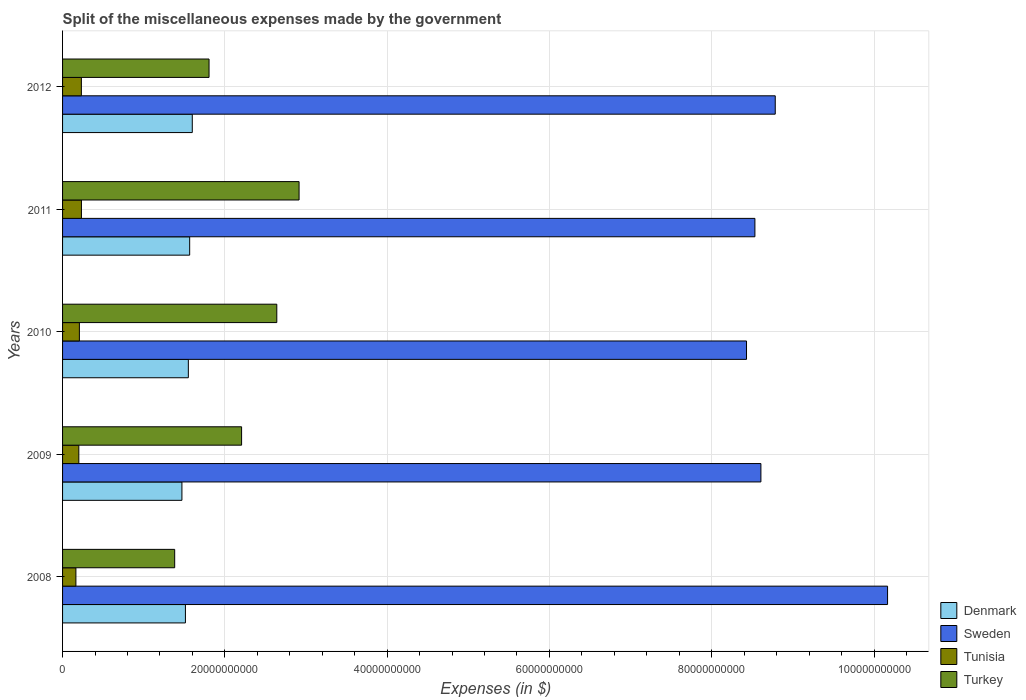How many bars are there on the 4th tick from the top?
Your answer should be very brief. 4. How many bars are there on the 2nd tick from the bottom?
Provide a succinct answer. 4. What is the label of the 1st group of bars from the top?
Keep it short and to the point. 2012. What is the miscellaneous expenses made by the government in Denmark in 2012?
Your response must be concise. 1.60e+1. Across all years, what is the maximum miscellaneous expenses made by the government in Denmark?
Make the answer very short. 1.60e+1. Across all years, what is the minimum miscellaneous expenses made by the government in Denmark?
Your response must be concise. 1.47e+1. In which year was the miscellaneous expenses made by the government in Denmark maximum?
Give a very brief answer. 2012. In which year was the miscellaneous expenses made by the government in Denmark minimum?
Offer a very short reply. 2009. What is the total miscellaneous expenses made by the government in Tunisia in the graph?
Make the answer very short. 1.04e+1. What is the difference between the miscellaneous expenses made by the government in Sweden in 2010 and that in 2012?
Keep it short and to the point. -3.54e+09. What is the difference between the miscellaneous expenses made by the government in Turkey in 2010 and the miscellaneous expenses made by the government in Sweden in 2012?
Ensure brevity in your answer.  -6.14e+1. What is the average miscellaneous expenses made by the government in Turkey per year?
Make the answer very short. 2.19e+1. In the year 2010, what is the difference between the miscellaneous expenses made by the government in Sweden and miscellaneous expenses made by the government in Denmark?
Your answer should be very brief. 6.88e+1. What is the ratio of the miscellaneous expenses made by the government in Denmark in 2009 to that in 2011?
Make the answer very short. 0.94. What is the difference between the highest and the second highest miscellaneous expenses made by the government in Tunisia?
Keep it short and to the point. 7.20e+06. What is the difference between the highest and the lowest miscellaneous expenses made by the government in Denmark?
Offer a very short reply. 1.28e+09. What does the 4th bar from the top in 2012 represents?
Provide a short and direct response. Denmark. How many bars are there?
Offer a terse response. 20. Are all the bars in the graph horizontal?
Provide a succinct answer. Yes. Where does the legend appear in the graph?
Give a very brief answer. Bottom right. What is the title of the graph?
Ensure brevity in your answer.  Split of the miscellaneous expenses made by the government. What is the label or title of the X-axis?
Keep it short and to the point. Expenses (in $). What is the label or title of the Y-axis?
Provide a succinct answer. Years. What is the Expenses (in $) of Denmark in 2008?
Your response must be concise. 1.51e+1. What is the Expenses (in $) in Sweden in 2008?
Give a very brief answer. 1.02e+11. What is the Expenses (in $) of Tunisia in 2008?
Offer a terse response. 1.64e+09. What is the Expenses (in $) of Turkey in 2008?
Offer a very short reply. 1.38e+1. What is the Expenses (in $) of Denmark in 2009?
Offer a very short reply. 1.47e+1. What is the Expenses (in $) in Sweden in 2009?
Ensure brevity in your answer.  8.61e+1. What is the Expenses (in $) of Tunisia in 2009?
Keep it short and to the point. 2.00e+09. What is the Expenses (in $) of Turkey in 2009?
Offer a terse response. 2.21e+1. What is the Expenses (in $) of Denmark in 2010?
Your answer should be compact. 1.55e+1. What is the Expenses (in $) in Sweden in 2010?
Offer a terse response. 8.43e+1. What is the Expenses (in $) of Tunisia in 2010?
Offer a terse response. 2.07e+09. What is the Expenses (in $) in Turkey in 2010?
Provide a short and direct response. 2.64e+1. What is the Expenses (in $) of Denmark in 2011?
Your answer should be compact. 1.57e+1. What is the Expenses (in $) in Sweden in 2011?
Give a very brief answer. 8.53e+1. What is the Expenses (in $) in Tunisia in 2011?
Ensure brevity in your answer.  2.32e+09. What is the Expenses (in $) of Turkey in 2011?
Provide a succinct answer. 2.91e+1. What is the Expenses (in $) of Denmark in 2012?
Offer a very short reply. 1.60e+1. What is the Expenses (in $) in Sweden in 2012?
Offer a very short reply. 8.78e+1. What is the Expenses (in $) in Tunisia in 2012?
Your response must be concise. 2.32e+09. What is the Expenses (in $) of Turkey in 2012?
Provide a succinct answer. 1.81e+1. Across all years, what is the maximum Expenses (in $) in Denmark?
Your response must be concise. 1.60e+1. Across all years, what is the maximum Expenses (in $) in Sweden?
Ensure brevity in your answer.  1.02e+11. Across all years, what is the maximum Expenses (in $) of Tunisia?
Keep it short and to the point. 2.32e+09. Across all years, what is the maximum Expenses (in $) of Turkey?
Keep it short and to the point. 2.91e+1. Across all years, what is the minimum Expenses (in $) of Denmark?
Your answer should be very brief. 1.47e+1. Across all years, what is the minimum Expenses (in $) of Sweden?
Provide a succinct answer. 8.43e+1. Across all years, what is the minimum Expenses (in $) in Tunisia?
Provide a short and direct response. 1.64e+09. Across all years, what is the minimum Expenses (in $) in Turkey?
Offer a terse response. 1.38e+1. What is the total Expenses (in $) of Denmark in the graph?
Offer a terse response. 7.70e+1. What is the total Expenses (in $) in Sweden in the graph?
Ensure brevity in your answer.  4.45e+11. What is the total Expenses (in $) of Tunisia in the graph?
Offer a very short reply. 1.04e+1. What is the total Expenses (in $) of Turkey in the graph?
Offer a terse response. 1.09e+11. What is the difference between the Expenses (in $) in Denmark in 2008 and that in 2009?
Ensure brevity in your answer.  4.30e+08. What is the difference between the Expenses (in $) of Sweden in 2008 and that in 2009?
Give a very brief answer. 1.56e+1. What is the difference between the Expenses (in $) of Tunisia in 2008 and that in 2009?
Ensure brevity in your answer.  -3.60e+08. What is the difference between the Expenses (in $) in Turkey in 2008 and that in 2009?
Your answer should be compact. -8.25e+09. What is the difference between the Expenses (in $) of Denmark in 2008 and that in 2010?
Make the answer very short. -3.60e+08. What is the difference between the Expenses (in $) in Sweden in 2008 and that in 2010?
Keep it short and to the point. 1.74e+1. What is the difference between the Expenses (in $) in Tunisia in 2008 and that in 2010?
Offer a very short reply. -4.31e+08. What is the difference between the Expenses (in $) in Turkey in 2008 and that in 2010?
Your answer should be very brief. -1.26e+1. What is the difference between the Expenses (in $) in Denmark in 2008 and that in 2011?
Provide a succinct answer. -5.25e+08. What is the difference between the Expenses (in $) in Sweden in 2008 and that in 2011?
Offer a terse response. 1.63e+1. What is the difference between the Expenses (in $) in Tunisia in 2008 and that in 2011?
Make the answer very short. -6.82e+08. What is the difference between the Expenses (in $) of Turkey in 2008 and that in 2011?
Provide a short and direct response. -1.53e+1. What is the difference between the Expenses (in $) in Denmark in 2008 and that in 2012?
Provide a short and direct response. -8.46e+08. What is the difference between the Expenses (in $) of Sweden in 2008 and that in 2012?
Your answer should be very brief. 1.38e+1. What is the difference between the Expenses (in $) in Tunisia in 2008 and that in 2012?
Provide a short and direct response. -6.74e+08. What is the difference between the Expenses (in $) in Turkey in 2008 and that in 2012?
Give a very brief answer. -4.24e+09. What is the difference between the Expenses (in $) of Denmark in 2009 and that in 2010?
Provide a short and direct response. -7.90e+08. What is the difference between the Expenses (in $) in Sweden in 2009 and that in 2010?
Keep it short and to the point. 1.77e+09. What is the difference between the Expenses (in $) of Tunisia in 2009 and that in 2010?
Give a very brief answer. -7.06e+07. What is the difference between the Expenses (in $) in Turkey in 2009 and that in 2010?
Your answer should be compact. -4.34e+09. What is the difference between the Expenses (in $) in Denmark in 2009 and that in 2011?
Your response must be concise. -9.55e+08. What is the difference between the Expenses (in $) in Sweden in 2009 and that in 2011?
Provide a succinct answer. 7.40e+08. What is the difference between the Expenses (in $) of Tunisia in 2009 and that in 2011?
Ensure brevity in your answer.  -3.21e+08. What is the difference between the Expenses (in $) of Turkey in 2009 and that in 2011?
Keep it short and to the point. -7.08e+09. What is the difference between the Expenses (in $) in Denmark in 2009 and that in 2012?
Keep it short and to the point. -1.28e+09. What is the difference between the Expenses (in $) of Sweden in 2009 and that in 2012?
Offer a very short reply. -1.77e+09. What is the difference between the Expenses (in $) of Tunisia in 2009 and that in 2012?
Offer a terse response. -3.14e+08. What is the difference between the Expenses (in $) in Turkey in 2009 and that in 2012?
Give a very brief answer. 4.01e+09. What is the difference between the Expenses (in $) in Denmark in 2010 and that in 2011?
Keep it short and to the point. -1.65e+08. What is the difference between the Expenses (in $) of Sweden in 2010 and that in 2011?
Provide a succinct answer. -1.03e+09. What is the difference between the Expenses (in $) in Tunisia in 2010 and that in 2011?
Provide a succinct answer. -2.50e+08. What is the difference between the Expenses (in $) in Turkey in 2010 and that in 2011?
Provide a short and direct response. -2.75e+09. What is the difference between the Expenses (in $) of Denmark in 2010 and that in 2012?
Provide a succinct answer. -4.86e+08. What is the difference between the Expenses (in $) in Sweden in 2010 and that in 2012?
Ensure brevity in your answer.  -3.54e+09. What is the difference between the Expenses (in $) in Tunisia in 2010 and that in 2012?
Ensure brevity in your answer.  -2.43e+08. What is the difference between the Expenses (in $) in Turkey in 2010 and that in 2012?
Make the answer very short. 8.35e+09. What is the difference between the Expenses (in $) in Denmark in 2011 and that in 2012?
Offer a very short reply. -3.21e+08. What is the difference between the Expenses (in $) in Sweden in 2011 and that in 2012?
Make the answer very short. -2.51e+09. What is the difference between the Expenses (in $) of Tunisia in 2011 and that in 2012?
Keep it short and to the point. 7.20e+06. What is the difference between the Expenses (in $) in Turkey in 2011 and that in 2012?
Your answer should be compact. 1.11e+1. What is the difference between the Expenses (in $) in Denmark in 2008 and the Expenses (in $) in Sweden in 2009?
Your answer should be very brief. -7.09e+1. What is the difference between the Expenses (in $) of Denmark in 2008 and the Expenses (in $) of Tunisia in 2009?
Provide a short and direct response. 1.31e+1. What is the difference between the Expenses (in $) of Denmark in 2008 and the Expenses (in $) of Turkey in 2009?
Your answer should be compact. -6.92e+09. What is the difference between the Expenses (in $) of Sweden in 2008 and the Expenses (in $) of Tunisia in 2009?
Provide a succinct answer. 9.97e+1. What is the difference between the Expenses (in $) of Sweden in 2008 and the Expenses (in $) of Turkey in 2009?
Keep it short and to the point. 7.96e+1. What is the difference between the Expenses (in $) in Tunisia in 2008 and the Expenses (in $) in Turkey in 2009?
Your answer should be compact. -2.04e+1. What is the difference between the Expenses (in $) of Denmark in 2008 and the Expenses (in $) of Sweden in 2010?
Your answer should be very brief. -6.92e+1. What is the difference between the Expenses (in $) of Denmark in 2008 and the Expenses (in $) of Tunisia in 2010?
Your response must be concise. 1.31e+1. What is the difference between the Expenses (in $) of Denmark in 2008 and the Expenses (in $) of Turkey in 2010?
Ensure brevity in your answer.  -1.13e+1. What is the difference between the Expenses (in $) of Sweden in 2008 and the Expenses (in $) of Tunisia in 2010?
Your answer should be very brief. 9.96e+1. What is the difference between the Expenses (in $) in Sweden in 2008 and the Expenses (in $) in Turkey in 2010?
Your answer should be very brief. 7.53e+1. What is the difference between the Expenses (in $) of Tunisia in 2008 and the Expenses (in $) of Turkey in 2010?
Your answer should be very brief. -2.48e+1. What is the difference between the Expenses (in $) of Denmark in 2008 and the Expenses (in $) of Sweden in 2011?
Offer a very short reply. -7.02e+1. What is the difference between the Expenses (in $) in Denmark in 2008 and the Expenses (in $) in Tunisia in 2011?
Your answer should be very brief. 1.28e+1. What is the difference between the Expenses (in $) in Denmark in 2008 and the Expenses (in $) in Turkey in 2011?
Offer a terse response. -1.40e+1. What is the difference between the Expenses (in $) of Sweden in 2008 and the Expenses (in $) of Tunisia in 2011?
Give a very brief answer. 9.93e+1. What is the difference between the Expenses (in $) of Sweden in 2008 and the Expenses (in $) of Turkey in 2011?
Provide a succinct answer. 7.25e+1. What is the difference between the Expenses (in $) in Tunisia in 2008 and the Expenses (in $) in Turkey in 2011?
Your response must be concise. -2.75e+1. What is the difference between the Expenses (in $) of Denmark in 2008 and the Expenses (in $) of Sweden in 2012?
Offer a terse response. -7.27e+1. What is the difference between the Expenses (in $) of Denmark in 2008 and the Expenses (in $) of Tunisia in 2012?
Give a very brief answer. 1.28e+1. What is the difference between the Expenses (in $) in Denmark in 2008 and the Expenses (in $) in Turkey in 2012?
Your answer should be very brief. -2.91e+09. What is the difference between the Expenses (in $) of Sweden in 2008 and the Expenses (in $) of Tunisia in 2012?
Your response must be concise. 9.94e+1. What is the difference between the Expenses (in $) of Sweden in 2008 and the Expenses (in $) of Turkey in 2012?
Offer a terse response. 8.36e+1. What is the difference between the Expenses (in $) in Tunisia in 2008 and the Expenses (in $) in Turkey in 2012?
Offer a terse response. -1.64e+1. What is the difference between the Expenses (in $) in Denmark in 2009 and the Expenses (in $) in Sweden in 2010?
Provide a short and direct response. -6.96e+1. What is the difference between the Expenses (in $) of Denmark in 2009 and the Expenses (in $) of Tunisia in 2010?
Your answer should be very brief. 1.26e+1. What is the difference between the Expenses (in $) in Denmark in 2009 and the Expenses (in $) in Turkey in 2010?
Make the answer very short. -1.17e+1. What is the difference between the Expenses (in $) in Sweden in 2009 and the Expenses (in $) in Tunisia in 2010?
Your answer should be compact. 8.40e+1. What is the difference between the Expenses (in $) of Sweden in 2009 and the Expenses (in $) of Turkey in 2010?
Your answer should be compact. 5.97e+1. What is the difference between the Expenses (in $) of Tunisia in 2009 and the Expenses (in $) of Turkey in 2010?
Your answer should be compact. -2.44e+1. What is the difference between the Expenses (in $) of Denmark in 2009 and the Expenses (in $) of Sweden in 2011?
Provide a short and direct response. -7.06e+1. What is the difference between the Expenses (in $) in Denmark in 2009 and the Expenses (in $) in Tunisia in 2011?
Your answer should be compact. 1.24e+1. What is the difference between the Expenses (in $) of Denmark in 2009 and the Expenses (in $) of Turkey in 2011?
Give a very brief answer. -1.44e+1. What is the difference between the Expenses (in $) of Sweden in 2009 and the Expenses (in $) of Tunisia in 2011?
Offer a terse response. 8.37e+1. What is the difference between the Expenses (in $) of Sweden in 2009 and the Expenses (in $) of Turkey in 2011?
Offer a terse response. 5.69e+1. What is the difference between the Expenses (in $) of Tunisia in 2009 and the Expenses (in $) of Turkey in 2011?
Provide a succinct answer. -2.71e+1. What is the difference between the Expenses (in $) in Denmark in 2009 and the Expenses (in $) in Sweden in 2012?
Make the answer very short. -7.31e+1. What is the difference between the Expenses (in $) in Denmark in 2009 and the Expenses (in $) in Tunisia in 2012?
Your response must be concise. 1.24e+1. What is the difference between the Expenses (in $) in Denmark in 2009 and the Expenses (in $) in Turkey in 2012?
Offer a terse response. -3.34e+09. What is the difference between the Expenses (in $) of Sweden in 2009 and the Expenses (in $) of Tunisia in 2012?
Make the answer very short. 8.37e+1. What is the difference between the Expenses (in $) in Sweden in 2009 and the Expenses (in $) in Turkey in 2012?
Give a very brief answer. 6.80e+1. What is the difference between the Expenses (in $) in Tunisia in 2009 and the Expenses (in $) in Turkey in 2012?
Ensure brevity in your answer.  -1.60e+1. What is the difference between the Expenses (in $) in Denmark in 2010 and the Expenses (in $) in Sweden in 2011?
Keep it short and to the point. -6.98e+1. What is the difference between the Expenses (in $) in Denmark in 2010 and the Expenses (in $) in Tunisia in 2011?
Keep it short and to the point. 1.32e+1. What is the difference between the Expenses (in $) in Denmark in 2010 and the Expenses (in $) in Turkey in 2011?
Provide a succinct answer. -1.36e+1. What is the difference between the Expenses (in $) in Sweden in 2010 and the Expenses (in $) in Tunisia in 2011?
Give a very brief answer. 8.20e+1. What is the difference between the Expenses (in $) in Sweden in 2010 and the Expenses (in $) in Turkey in 2011?
Ensure brevity in your answer.  5.51e+1. What is the difference between the Expenses (in $) in Tunisia in 2010 and the Expenses (in $) in Turkey in 2011?
Make the answer very short. -2.71e+1. What is the difference between the Expenses (in $) of Denmark in 2010 and the Expenses (in $) of Sweden in 2012?
Make the answer very short. -7.23e+1. What is the difference between the Expenses (in $) of Denmark in 2010 and the Expenses (in $) of Tunisia in 2012?
Your answer should be very brief. 1.32e+1. What is the difference between the Expenses (in $) in Denmark in 2010 and the Expenses (in $) in Turkey in 2012?
Offer a very short reply. -2.55e+09. What is the difference between the Expenses (in $) of Sweden in 2010 and the Expenses (in $) of Tunisia in 2012?
Your response must be concise. 8.20e+1. What is the difference between the Expenses (in $) of Sweden in 2010 and the Expenses (in $) of Turkey in 2012?
Keep it short and to the point. 6.62e+1. What is the difference between the Expenses (in $) in Tunisia in 2010 and the Expenses (in $) in Turkey in 2012?
Your answer should be compact. -1.60e+1. What is the difference between the Expenses (in $) of Denmark in 2011 and the Expenses (in $) of Sweden in 2012?
Provide a succinct answer. -7.22e+1. What is the difference between the Expenses (in $) of Denmark in 2011 and the Expenses (in $) of Tunisia in 2012?
Ensure brevity in your answer.  1.33e+1. What is the difference between the Expenses (in $) in Denmark in 2011 and the Expenses (in $) in Turkey in 2012?
Your answer should be compact. -2.39e+09. What is the difference between the Expenses (in $) in Sweden in 2011 and the Expenses (in $) in Tunisia in 2012?
Your response must be concise. 8.30e+1. What is the difference between the Expenses (in $) of Sweden in 2011 and the Expenses (in $) of Turkey in 2012?
Your answer should be very brief. 6.73e+1. What is the difference between the Expenses (in $) in Tunisia in 2011 and the Expenses (in $) in Turkey in 2012?
Your answer should be compact. -1.57e+1. What is the average Expenses (in $) of Denmark per year?
Ensure brevity in your answer.  1.54e+1. What is the average Expenses (in $) of Sweden per year?
Offer a very short reply. 8.90e+1. What is the average Expenses (in $) in Tunisia per year?
Your response must be concise. 2.07e+09. What is the average Expenses (in $) in Turkey per year?
Your answer should be very brief. 2.19e+1. In the year 2008, what is the difference between the Expenses (in $) of Denmark and Expenses (in $) of Sweden?
Provide a succinct answer. -8.65e+1. In the year 2008, what is the difference between the Expenses (in $) in Denmark and Expenses (in $) in Tunisia?
Your response must be concise. 1.35e+1. In the year 2008, what is the difference between the Expenses (in $) of Denmark and Expenses (in $) of Turkey?
Your response must be concise. 1.32e+09. In the year 2008, what is the difference between the Expenses (in $) in Sweden and Expenses (in $) in Tunisia?
Give a very brief answer. 1.00e+11. In the year 2008, what is the difference between the Expenses (in $) of Sweden and Expenses (in $) of Turkey?
Keep it short and to the point. 8.79e+1. In the year 2008, what is the difference between the Expenses (in $) in Tunisia and Expenses (in $) in Turkey?
Ensure brevity in your answer.  -1.22e+1. In the year 2009, what is the difference between the Expenses (in $) in Denmark and Expenses (in $) in Sweden?
Ensure brevity in your answer.  -7.14e+1. In the year 2009, what is the difference between the Expenses (in $) in Denmark and Expenses (in $) in Tunisia?
Make the answer very short. 1.27e+1. In the year 2009, what is the difference between the Expenses (in $) of Denmark and Expenses (in $) of Turkey?
Your answer should be very brief. -7.35e+09. In the year 2009, what is the difference between the Expenses (in $) of Sweden and Expenses (in $) of Tunisia?
Your answer should be compact. 8.41e+1. In the year 2009, what is the difference between the Expenses (in $) of Sweden and Expenses (in $) of Turkey?
Provide a short and direct response. 6.40e+1. In the year 2009, what is the difference between the Expenses (in $) of Tunisia and Expenses (in $) of Turkey?
Provide a short and direct response. -2.01e+1. In the year 2010, what is the difference between the Expenses (in $) in Denmark and Expenses (in $) in Sweden?
Ensure brevity in your answer.  -6.88e+1. In the year 2010, what is the difference between the Expenses (in $) of Denmark and Expenses (in $) of Tunisia?
Offer a very short reply. 1.34e+1. In the year 2010, what is the difference between the Expenses (in $) in Denmark and Expenses (in $) in Turkey?
Your answer should be very brief. -1.09e+1. In the year 2010, what is the difference between the Expenses (in $) of Sweden and Expenses (in $) of Tunisia?
Provide a succinct answer. 8.22e+1. In the year 2010, what is the difference between the Expenses (in $) of Sweden and Expenses (in $) of Turkey?
Provide a short and direct response. 5.79e+1. In the year 2010, what is the difference between the Expenses (in $) in Tunisia and Expenses (in $) in Turkey?
Provide a succinct answer. -2.43e+1. In the year 2011, what is the difference between the Expenses (in $) of Denmark and Expenses (in $) of Sweden?
Your answer should be compact. -6.97e+1. In the year 2011, what is the difference between the Expenses (in $) in Denmark and Expenses (in $) in Tunisia?
Offer a very short reply. 1.33e+1. In the year 2011, what is the difference between the Expenses (in $) in Denmark and Expenses (in $) in Turkey?
Your answer should be very brief. -1.35e+1. In the year 2011, what is the difference between the Expenses (in $) of Sweden and Expenses (in $) of Tunisia?
Offer a terse response. 8.30e+1. In the year 2011, what is the difference between the Expenses (in $) of Sweden and Expenses (in $) of Turkey?
Give a very brief answer. 5.62e+1. In the year 2011, what is the difference between the Expenses (in $) of Tunisia and Expenses (in $) of Turkey?
Give a very brief answer. -2.68e+1. In the year 2012, what is the difference between the Expenses (in $) in Denmark and Expenses (in $) in Sweden?
Your response must be concise. -7.18e+1. In the year 2012, what is the difference between the Expenses (in $) of Denmark and Expenses (in $) of Tunisia?
Your answer should be compact. 1.37e+1. In the year 2012, what is the difference between the Expenses (in $) in Denmark and Expenses (in $) in Turkey?
Provide a short and direct response. -2.07e+09. In the year 2012, what is the difference between the Expenses (in $) of Sweden and Expenses (in $) of Tunisia?
Offer a very short reply. 8.55e+1. In the year 2012, what is the difference between the Expenses (in $) of Sweden and Expenses (in $) of Turkey?
Your answer should be compact. 6.98e+1. In the year 2012, what is the difference between the Expenses (in $) in Tunisia and Expenses (in $) in Turkey?
Your response must be concise. -1.57e+1. What is the ratio of the Expenses (in $) of Denmark in 2008 to that in 2009?
Offer a terse response. 1.03. What is the ratio of the Expenses (in $) of Sweden in 2008 to that in 2009?
Your answer should be compact. 1.18. What is the ratio of the Expenses (in $) of Tunisia in 2008 to that in 2009?
Your response must be concise. 0.82. What is the ratio of the Expenses (in $) of Turkey in 2008 to that in 2009?
Ensure brevity in your answer.  0.63. What is the ratio of the Expenses (in $) in Denmark in 2008 to that in 2010?
Provide a succinct answer. 0.98. What is the ratio of the Expenses (in $) in Sweden in 2008 to that in 2010?
Your answer should be compact. 1.21. What is the ratio of the Expenses (in $) in Tunisia in 2008 to that in 2010?
Offer a very short reply. 0.79. What is the ratio of the Expenses (in $) of Turkey in 2008 to that in 2010?
Offer a very short reply. 0.52. What is the ratio of the Expenses (in $) in Denmark in 2008 to that in 2011?
Your answer should be compact. 0.97. What is the ratio of the Expenses (in $) in Sweden in 2008 to that in 2011?
Offer a very short reply. 1.19. What is the ratio of the Expenses (in $) of Tunisia in 2008 to that in 2011?
Keep it short and to the point. 0.71. What is the ratio of the Expenses (in $) in Turkey in 2008 to that in 2011?
Ensure brevity in your answer.  0.47. What is the ratio of the Expenses (in $) of Denmark in 2008 to that in 2012?
Your answer should be very brief. 0.95. What is the ratio of the Expenses (in $) in Sweden in 2008 to that in 2012?
Give a very brief answer. 1.16. What is the ratio of the Expenses (in $) in Tunisia in 2008 to that in 2012?
Provide a short and direct response. 0.71. What is the ratio of the Expenses (in $) in Turkey in 2008 to that in 2012?
Your answer should be compact. 0.77. What is the ratio of the Expenses (in $) of Denmark in 2009 to that in 2010?
Provide a succinct answer. 0.95. What is the ratio of the Expenses (in $) in Sweden in 2009 to that in 2010?
Offer a very short reply. 1.02. What is the ratio of the Expenses (in $) of Turkey in 2009 to that in 2010?
Give a very brief answer. 0.84. What is the ratio of the Expenses (in $) of Denmark in 2009 to that in 2011?
Give a very brief answer. 0.94. What is the ratio of the Expenses (in $) of Sweden in 2009 to that in 2011?
Offer a very short reply. 1.01. What is the ratio of the Expenses (in $) of Tunisia in 2009 to that in 2011?
Your answer should be compact. 0.86. What is the ratio of the Expenses (in $) in Turkey in 2009 to that in 2011?
Ensure brevity in your answer.  0.76. What is the ratio of the Expenses (in $) of Denmark in 2009 to that in 2012?
Keep it short and to the point. 0.92. What is the ratio of the Expenses (in $) of Sweden in 2009 to that in 2012?
Give a very brief answer. 0.98. What is the ratio of the Expenses (in $) in Tunisia in 2009 to that in 2012?
Your answer should be compact. 0.86. What is the ratio of the Expenses (in $) in Turkey in 2009 to that in 2012?
Offer a very short reply. 1.22. What is the ratio of the Expenses (in $) of Sweden in 2010 to that in 2011?
Give a very brief answer. 0.99. What is the ratio of the Expenses (in $) in Tunisia in 2010 to that in 2011?
Keep it short and to the point. 0.89. What is the ratio of the Expenses (in $) in Turkey in 2010 to that in 2011?
Offer a terse response. 0.91. What is the ratio of the Expenses (in $) of Denmark in 2010 to that in 2012?
Keep it short and to the point. 0.97. What is the ratio of the Expenses (in $) of Sweden in 2010 to that in 2012?
Your answer should be compact. 0.96. What is the ratio of the Expenses (in $) of Tunisia in 2010 to that in 2012?
Offer a very short reply. 0.9. What is the ratio of the Expenses (in $) in Turkey in 2010 to that in 2012?
Your answer should be compact. 1.46. What is the ratio of the Expenses (in $) of Denmark in 2011 to that in 2012?
Provide a short and direct response. 0.98. What is the ratio of the Expenses (in $) in Sweden in 2011 to that in 2012?
Give a very brief answer. 0.97. What is the ratio of the Expenses (in $) in Turkey in 2011 to that in 2012?
Offer a terse response. 1.61. What is the difference between the highest and the second highest Expenses (in $) in Denmark?
Ensure brevity in your answer.  3.21e+08. What is the difference between the highest and the second highest Expenses (in $) in Sweden?
Make the answer very short. 1.38e+1. What is the difference between the highest and the second highest Expenses (in $) of Tunisia?
Make the answer very short. 7.20e+06. What is the difference between the highest and the second highest Expenses (in $) in Turkey?
Provide a succinct answer. 2.75e+09. What is the difference between the highest and the lowest Expenses (in $) in Denmark?
Your answer should be compact. 1.28e+09. What is the difference between the highest and the lowest Expenses (in $) in Sweden?
Offer a very short reply. 1.74e+1. What is the difference between the highest and the lowest Expenses (in $) of Tunisia?
Make the answer very short. 6.82e+08. What is the difference between the highest and the lowest Expenses (in $) of Turkey?
Provide a short and direct response. 1.53e+1. 